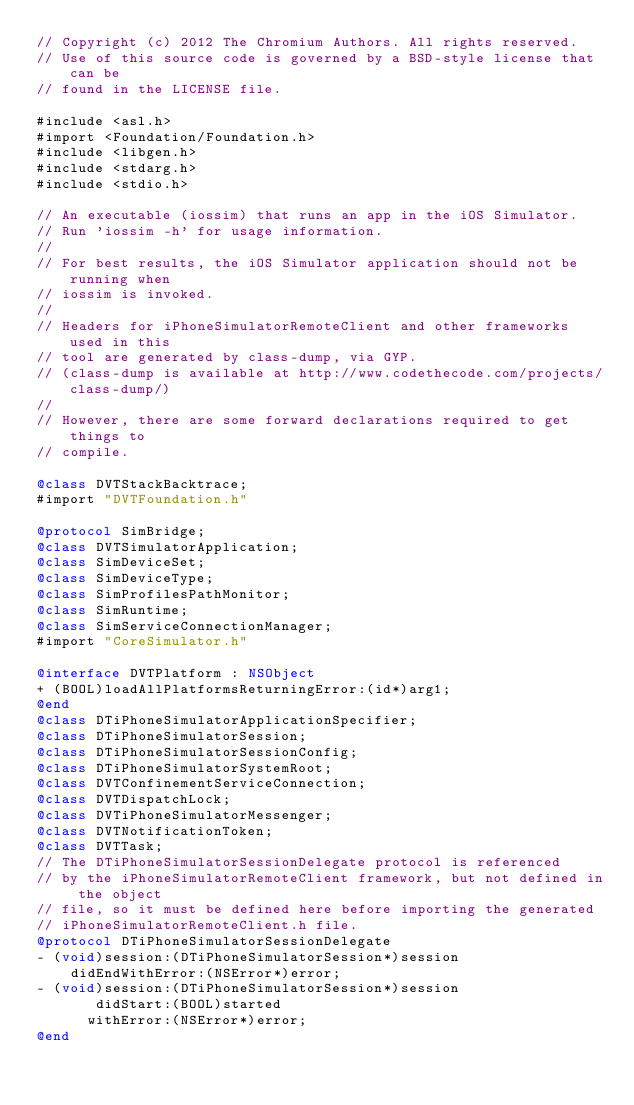Convert code to text. <code><loc_0><loc_0><loc_500><loc_500><_ObjectiveC_>// Copyright (c) 2012 The Chromium Authors. All rights reserved.
// Use of this source code is governed by a BSD-style license that can be
// found in the LICENSE file.

#include <asl.h>
#import <Foundation/Foundation.h>
#include <libgen.h>
#include <stdarg.h>
#include <stdio.h>

// An executable (iossim) that runs an app in the iOS Simulator.
// Run 'iossim -h' for usage information.
//
// For best results, the iOS Simulator application should not be running when
// iossim is invoked.
//
// Headers for iPhoneSimulatorRemoteClient and other frameworks used in this
// tool are generated by class-dump, via GYP.
// (class-dump is available at http://www.codethecode.com/projects/class-dump/)
//
// However, there are some forward declarations required to get things to
// compile.

@class DVTStackBacktrace;
#import "DVTFoundation.h"

@protocol SimBridge;
@class DVTSimulatorApplication;
@class SimDeviceSet;
@class SimDeviceType;
@class SimProfilesPathMonitor;
@class SimRuntime;
@class SimServiceConnectionManager;
#import "CoreSimulator.h"

@interface DVTPlatform : NSObject
+ (BOOL)loadAllPlatformsReturningError:(id*)arg1;
@end
@class DTiPhoneSimulatorApplicationSpecifier;
@class DTiPhoneSimulatorSession;
@class DTiPhoneSimulatorSessionConfig;
@class DTiPhoneSimulatorSystemRoot;
@class DVTConfinementServiceConnection;
@class DVTDispatchLock;
@class DVTiPhoneSimulatorMessenger;
@class DVTNotificationToken;
@class DVTTask;
// The DTiPhoneSimulatorSessionDelegate protocol is referenced
// by the iPhoneSimulatorRemoteClient framework, but not defined in the object
// file, so it must be defined here before importing the generated
// iPhoneSimulatorRemoteClient.h file.
@protocol DTiPhoneSimulatorSessionDelegate
- (void)session:(DTiPhoneSimulatorSession*)session
    didEndWithError:(NSError*)error;
- (void)session:(DTiPhoneSimulatorSession*)session
       didStart:(BOOL)started
      withError:(NSError*)error;
@end</code> 